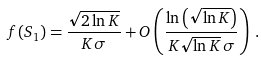Convert formula to latex. <formula><loc_0><loc_0><loc_500><loc_500>f ( S _ { 1 } ) = \frac { \sqrt { 2 \ln K } } { K \sigma } + O \left ( \frac { \ln \left ( \sqrt { \ln K } \right ) } { K \sqrt { \ln K } \, \sigma } \right ) \, .</formula> 